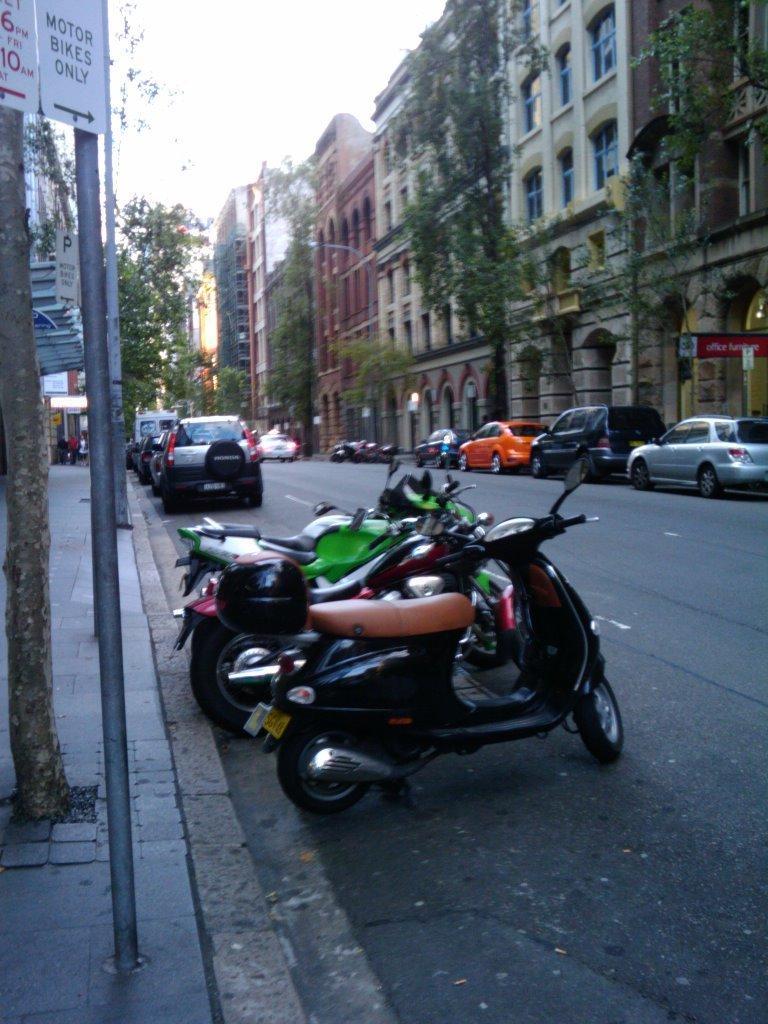In one or two sentences, can you explain what this image depicts? There are bikes and cars on the road. Here we can see poles, boards, trees, lights, and buildings. In the background there is sky. 